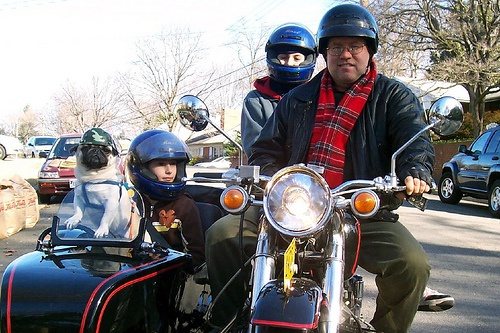Describe the objects in this image and their specific colors. I can see people in white, black, gray, maroon, and brown tones, motorcycle in white, black, gray, and darkgray tones, people in white, black, gray, and navy tones, dog in white, lightgray, darkgray, black, and gray tones, and people in white, black, navy, gray, and blue tones in this image. 